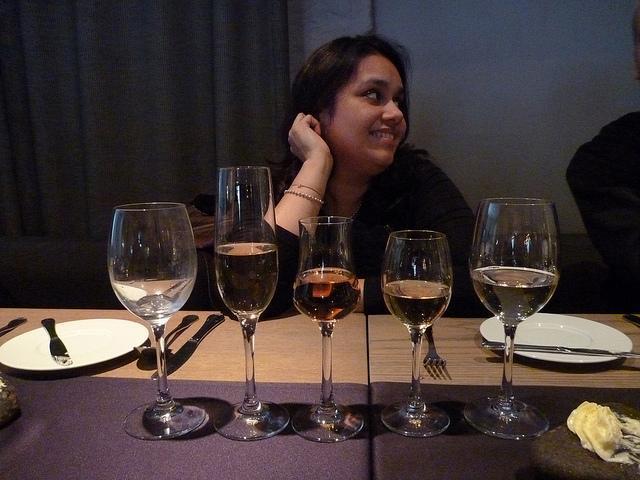How many pieces of cutlery are in the picture?
Give a very brief answer. 6. How many glasses are on the table?
Give a very brief answer. 5. How many people are in the picture?
Give a very brief answer. 1. How many people are visible?
Give a very brief answer. 2. How many wine glasses are in the picture?
Give a very brief answer. 5. 